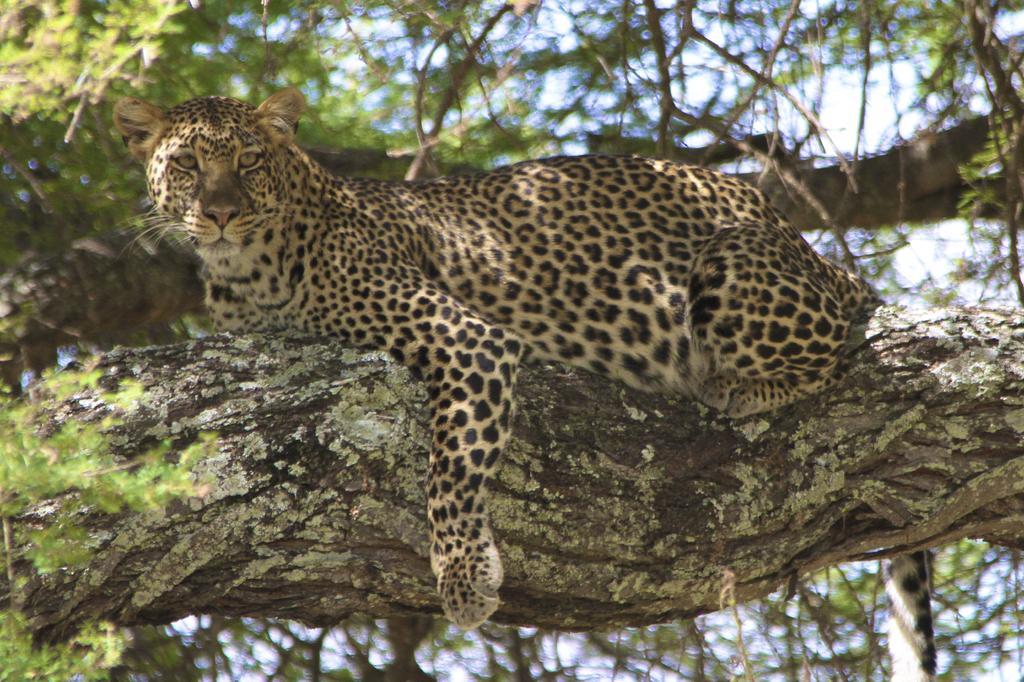Please provide a concise description of this image. In this image I can see a leopard on the branch of a tree. The background of the image is blurred. 